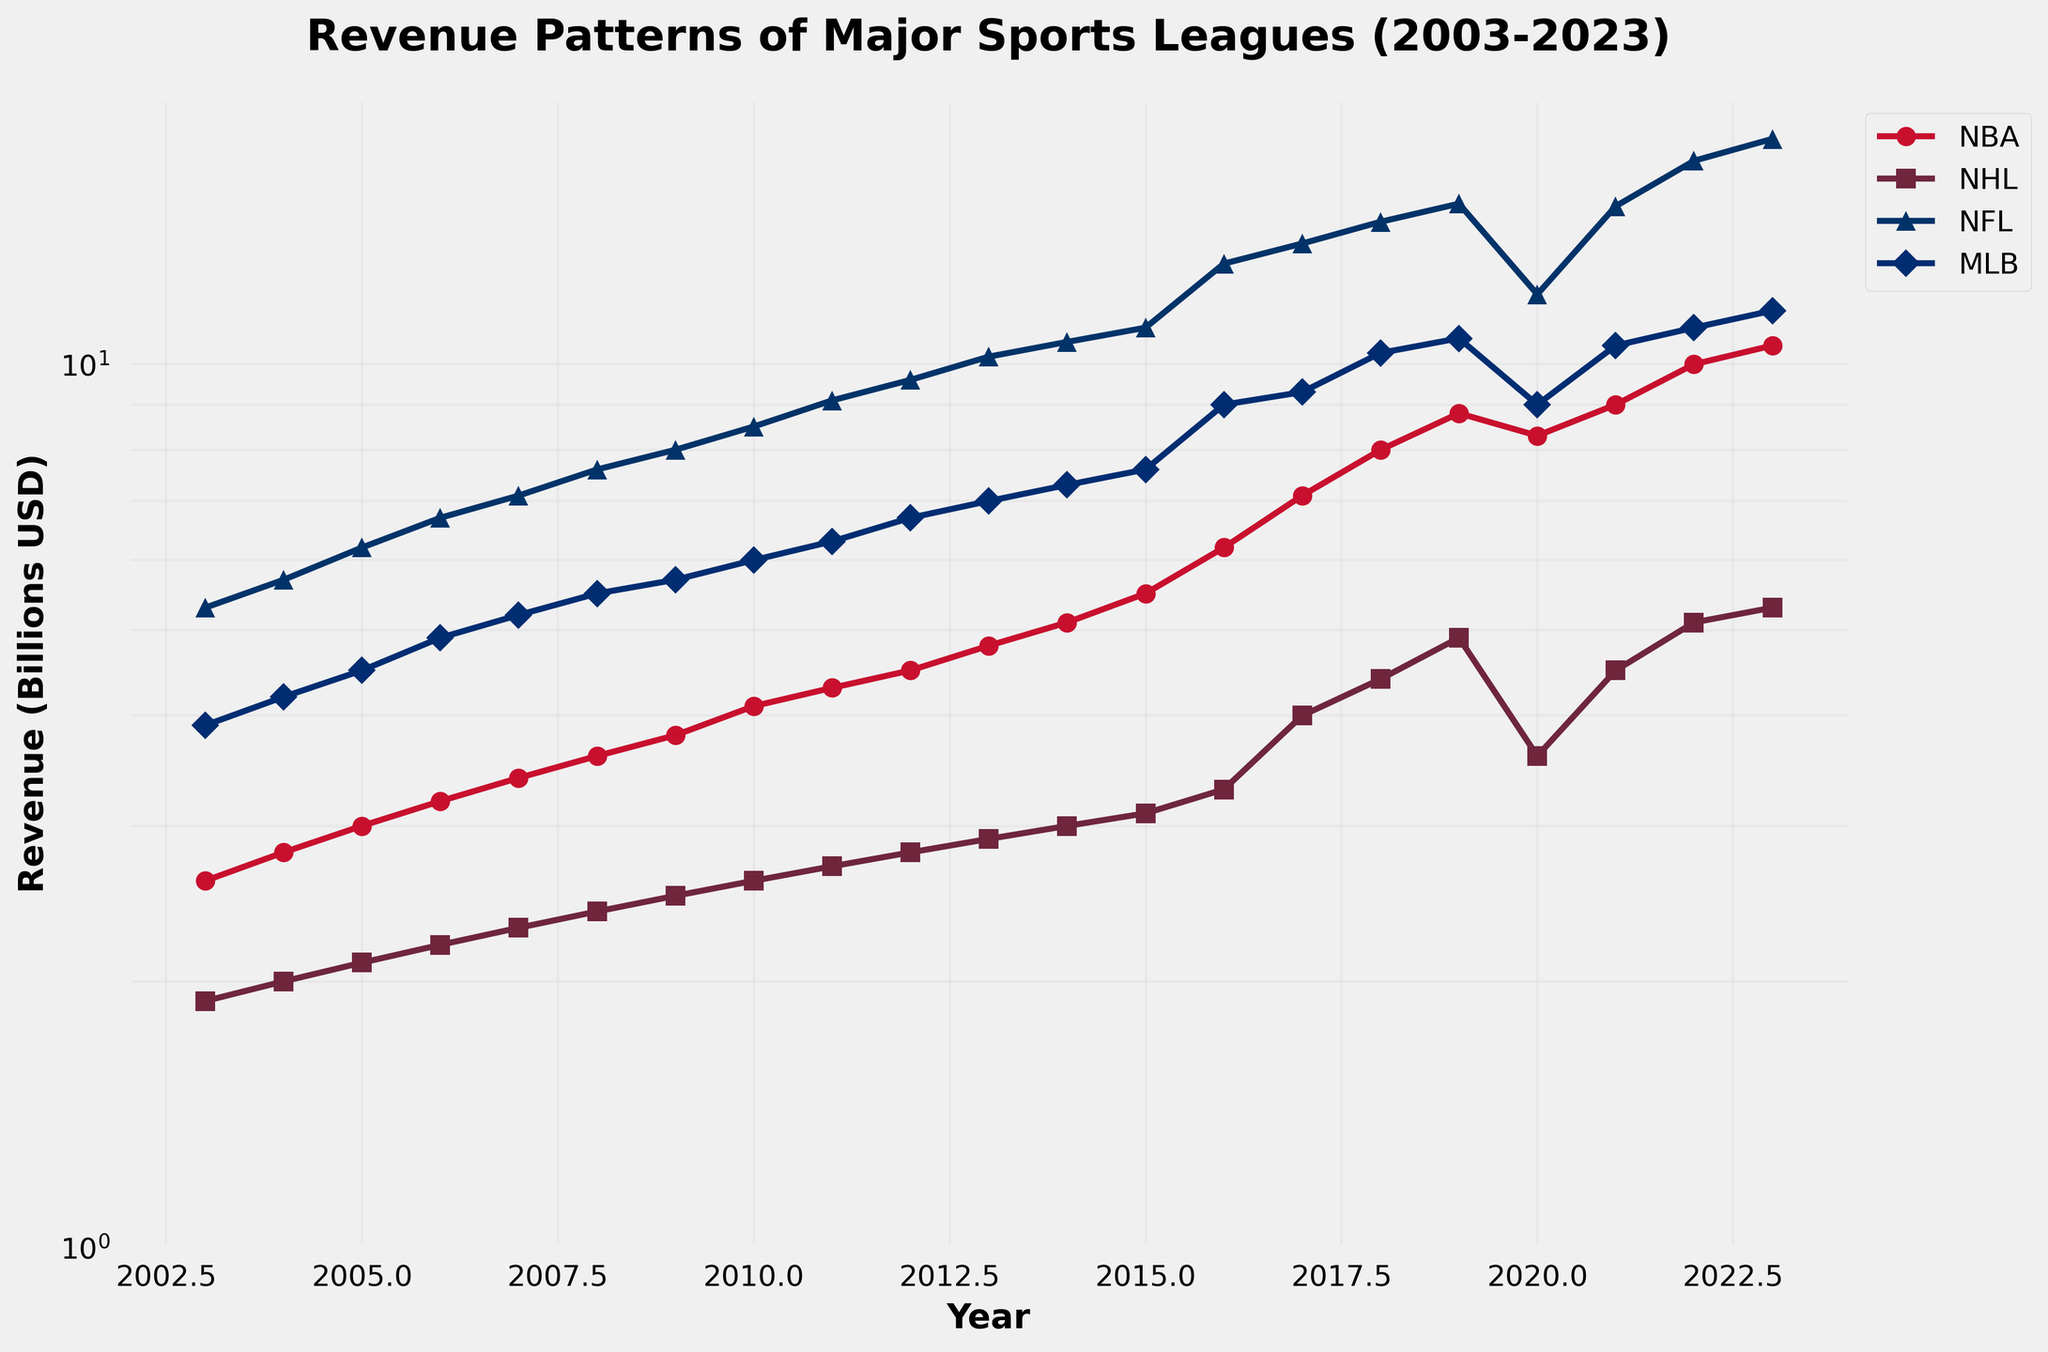what is the title of the plot? The title of the plot is located at the top and provides an overview of what the plot represents. It reads 'Revenue Patterns of Major Sports Leagues (2003-2023)'.
Answer: Revenue Patterns of Major Sports Leagues (2003-2023) what is the range of the y-axis in the plot? The y-axis range is displayed along the vertical side of the plot, starting from 1 billion USD up to 20 billion USD, due to the log scale.
Answer: 1 to 20 billion USD which league has the highest revenue in 2023? By examining the trends close to 2023 on the horizontal axis, it can be observed that the NFL's line is at the top with a revenue of 18 billion USD.
Answer: NFL which league shows the steepest growth in revenue between 2016 and 2023? Between 2016 and 2023, the plots need to be compared. The NBA line shows the most significant upward trend within this period, growing from 6.2 billion USD to 10.5 billion USD.
Answer: NBA how did the NHL's revenue change from 2019 to 2020 and then to 2021? The NHL's revenue drops from 4.9 billion USD in 2019 to 3.6 billion USD in 2020, and then rebounded to 4.5 billion USD in 2021; closely following the decline and subsequent recovery trend.
Answer: Decreased then increased which league's revenue was least affected by the dip around 2020? By observing the revenue of all leagues around 2020, NFL's line shows the least deviation, dropping from 15.2 billion USD in 2019 to 12.0 billion USD in 2020, and recovering back up to 15.1 billion USD in 2021.
Answer: NFL what is the average revenue for MLB between 2018 and 2023? To find the average, sum the MLB's revenue values from 2018 to 2023: 10.3 + 10.7 + 9.0 + 10.5 + 11.0 + 11.5 = 63 billion USD, then divide by the number of data points, 6, yielding 63/6 = 10.5 billion USD.
Answer: 10.5 billion USD which two leagues have similar revenue patterns in the years immediately following 2020? Reviewing the trends right after 2020, both the NHL and MLB exhibit similar rising patterns, with revenues increasing from the dips in 2020 and corresponding trends up thereafter.
Answer: NHL and MLB how can you tell that the y-axis is on a logarithmic scale? The spacing of the values on the y-axis increases exponentially, doubling at intervals rather than linearly, indicative of a logarithmic scale. Also, the "log" mention in the y-axis gridlines suggests this.
Answer: Exponentially spaced values between 2003 and 2023, which league had the most consistent revenue growth? Assessing the slope of lines over the two decades, the NFL displays the most consistent and steady revenue growth, as indicated by its nearly straight and upward trajectory.
Answer: NFL 